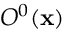Convert formula to latex. <formula><loc_0><loc_0><loc_500><loc_500>O ^ { 0 } ( x )</formula> 